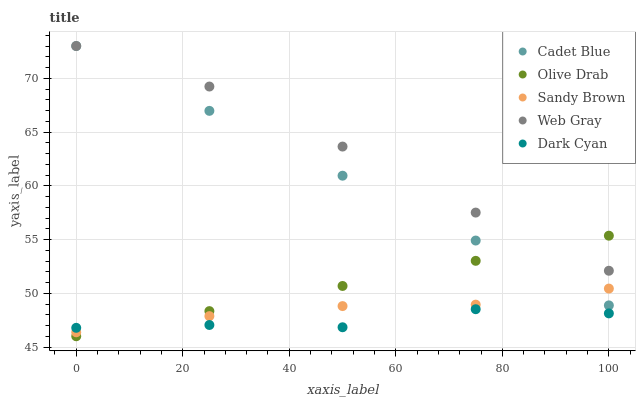Does Dark Cyan have the minimum area under the curve?
Answer yes or no. Yes. Does Web Gray have the maximum area under the curve?
Answer yes or no. Yes. Does Cadet Blue have the minimum area under the curve?
Answer yes or no. No. Does Cadet Blue have the maximum area under the curve?
Answer yes or no. No. Is Cadet Blue the smoothest?
Answer yes or no. Yes. Is Dark Cyan the roughest?
Answer yes or no. Yes. Is Dark Cyan the smoothest?
Answer yes or no. No. Is Cadet Blue the roughest?
Answer yes or no. No. Does Olive Drab have the lowest value?
Answer yes or no. Yes. Does Dark Cyan have the lowest value?
Answer yes or no. No. Does Cadet Blue have the highest value?
Answer yes or no. Yes. Does Dark Cyan have the highest value?
Answer yes or no. No. Is Sandy Brown less than Web Gray?
Answer yes or no. Yes. Is Cadet Blue greater than Dark Cyan?
Answer yes or no. Yes. Does Sandy Brown intersect Olive Drab?
Answer yes or no. Yes. Is Sandy Brown less than Olive Drab?
Answer yes or no. No. Is Sandy Brown greater than Olive Drab?
Answer yes or no. No. Does Sandy Brown intersect Web Gray?
Answer yes or no. No. 